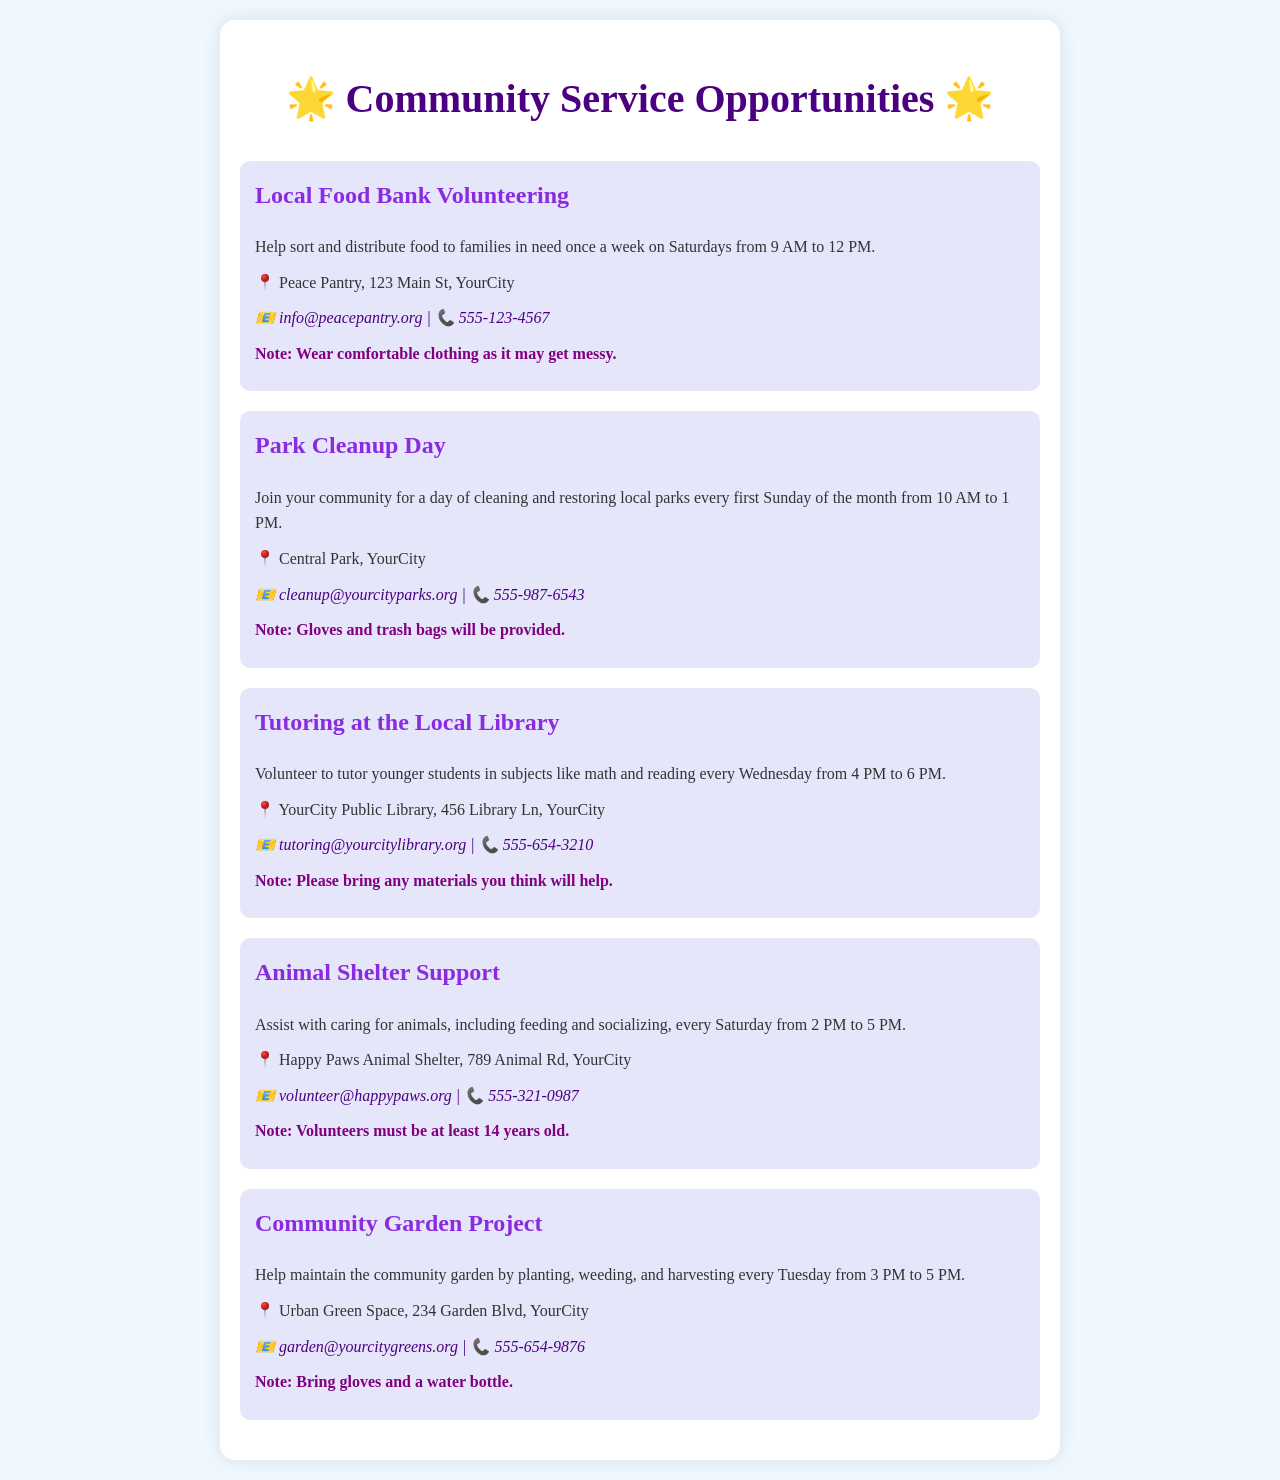What is the first opportunity listed? The first opportunity listed is the Local Food Bank Volunteering.
Answer: Local Food Bank Volunteering When does the Park Cleanup Day occur? The Park Cleanup Day occurs every first Sunday of the month.
Answer: first Sunday of the month What time does tutoring at the library start? Tutoring at the library starts at 4 PM.
Answer: 4 PM How often do volunteers help at the Animal Shelter? Volunteers help at the Animal Shelter every Saturday.
Answer: every Saturday What is the contact email for the Community Garden Project? The contact email for the Community Garden Project is garden@yourcitygreens.org.
Answer: garden@yourcitygreens.org How many hours is the Local Food Bank Volunteering session? The Local Food Bank Volunteering session is three hours long.
Answer: three hours Which opportunity requires that volunteers must be at least 14 years old? The opportunity that requires volunteers to be at least 14 years old is the Animal Shelter Support.
Answer: Animal Shelter Support What should you bring to the Community Garden Project? You should bring gloves and a water bottle.
Answer: gloves and a water bottle What type of assistance is provided during the Tutoring at the Local Library? The assistance provided is tutoring younger students.
Answer: tutoring younger students 